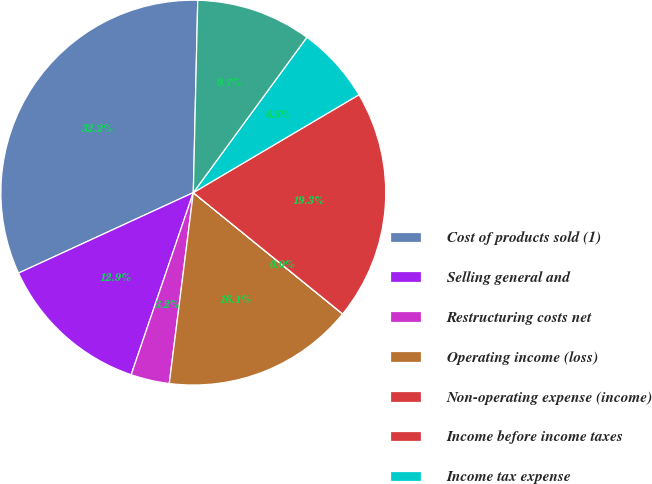Convert chart. <chart><loc_0><loc_0><loc_500><loc_500><pie_chart><fcel>Cost of products sold (1)<fcel>Selling general and<fcel>Restructuring costs net<fcel>Operating income (loss)<fcel>Non-operating expense (income)<fcel>Income before income taxes<fcel>Income tax expense<fcel>Net income (loss)<nl><fcel>32.24%<fcel>12.9%<fcel>3.24%<fcel>16.13%<fcel>0.01%<fcel>19.35%<fcel>6.46%<fcel>9.68%<nl></chart> 